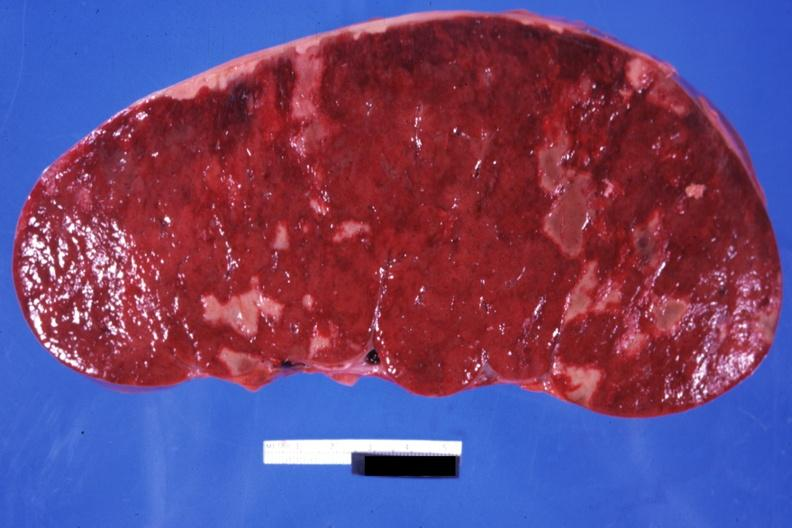what is present?
Answer the question using a single word or phrase. Hematologic 